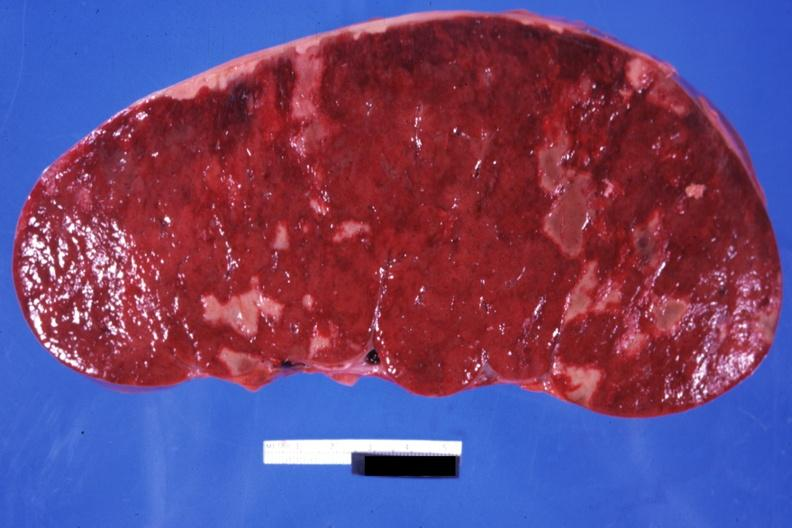what is present?
Answer the question using a single word or phrase. Hematologic 